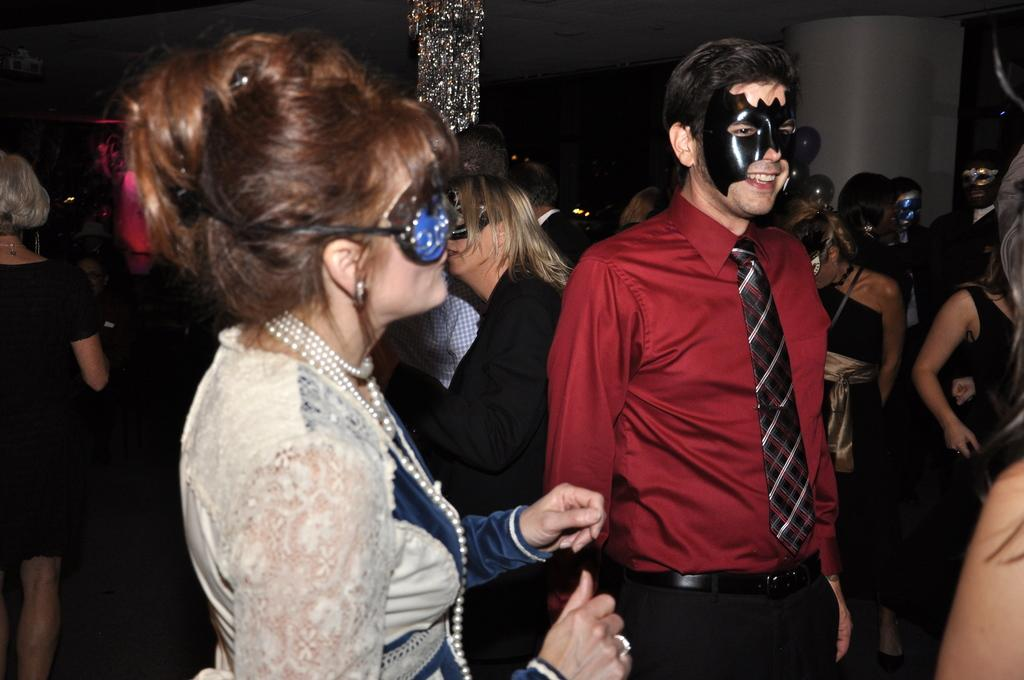Who or what can be seen in the image? There are people in the image. What are some of the people wearing? Some of the people are wearing masks. What type of lighting fixture is present in the image? There is a chandelier in the image. What type of architectural feature is visible in the image? There is a wall in the image. What is the level of wealth of the people in the image based on their clothing? The level of wealth of the people cannot be determined based on their clothing in the image, as no specific details about their clothing are provided. 